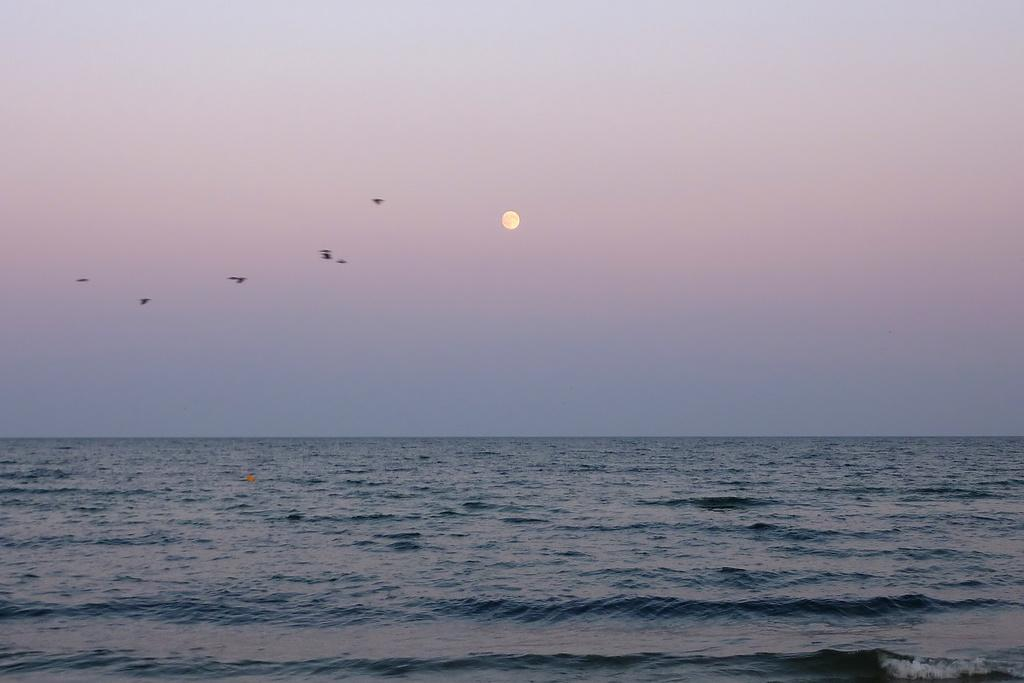What type of animals can be seen in the image? Birds can be seen in the image. What is the primary element in which the birds are situated? The birds are situated in water. What part of the natural environment is visible in the image? The sky is visible in the image. What type of worm is the mother feeding to the birds in the image? There is no mother or worm present in the image; it features birds in the water. 